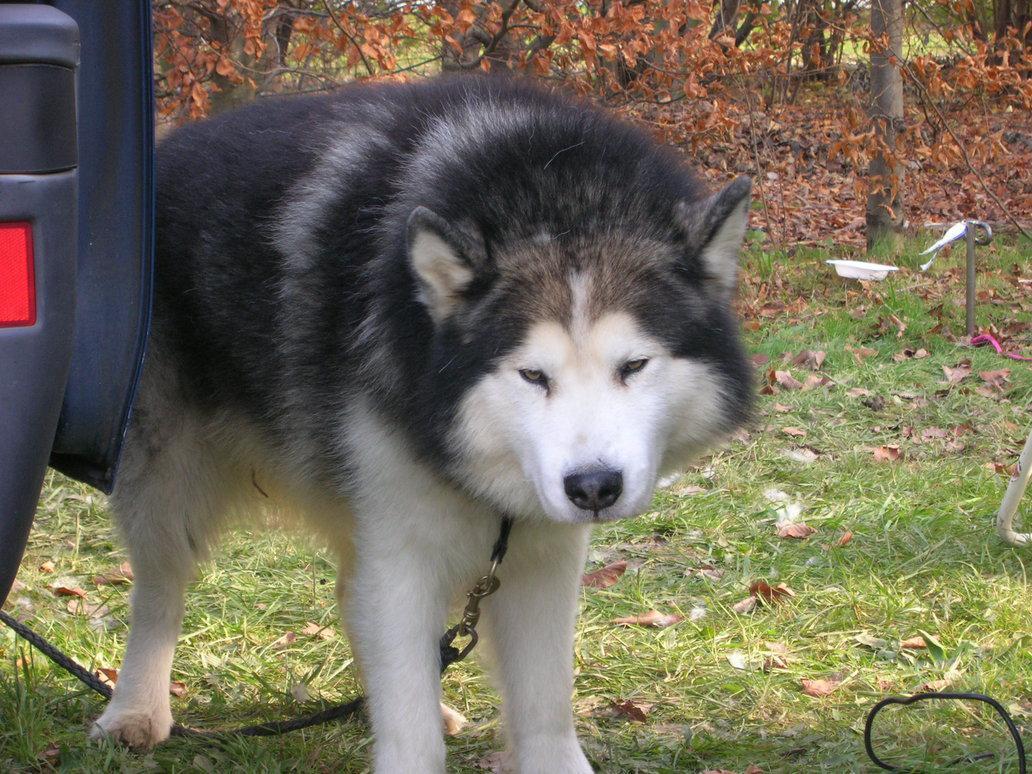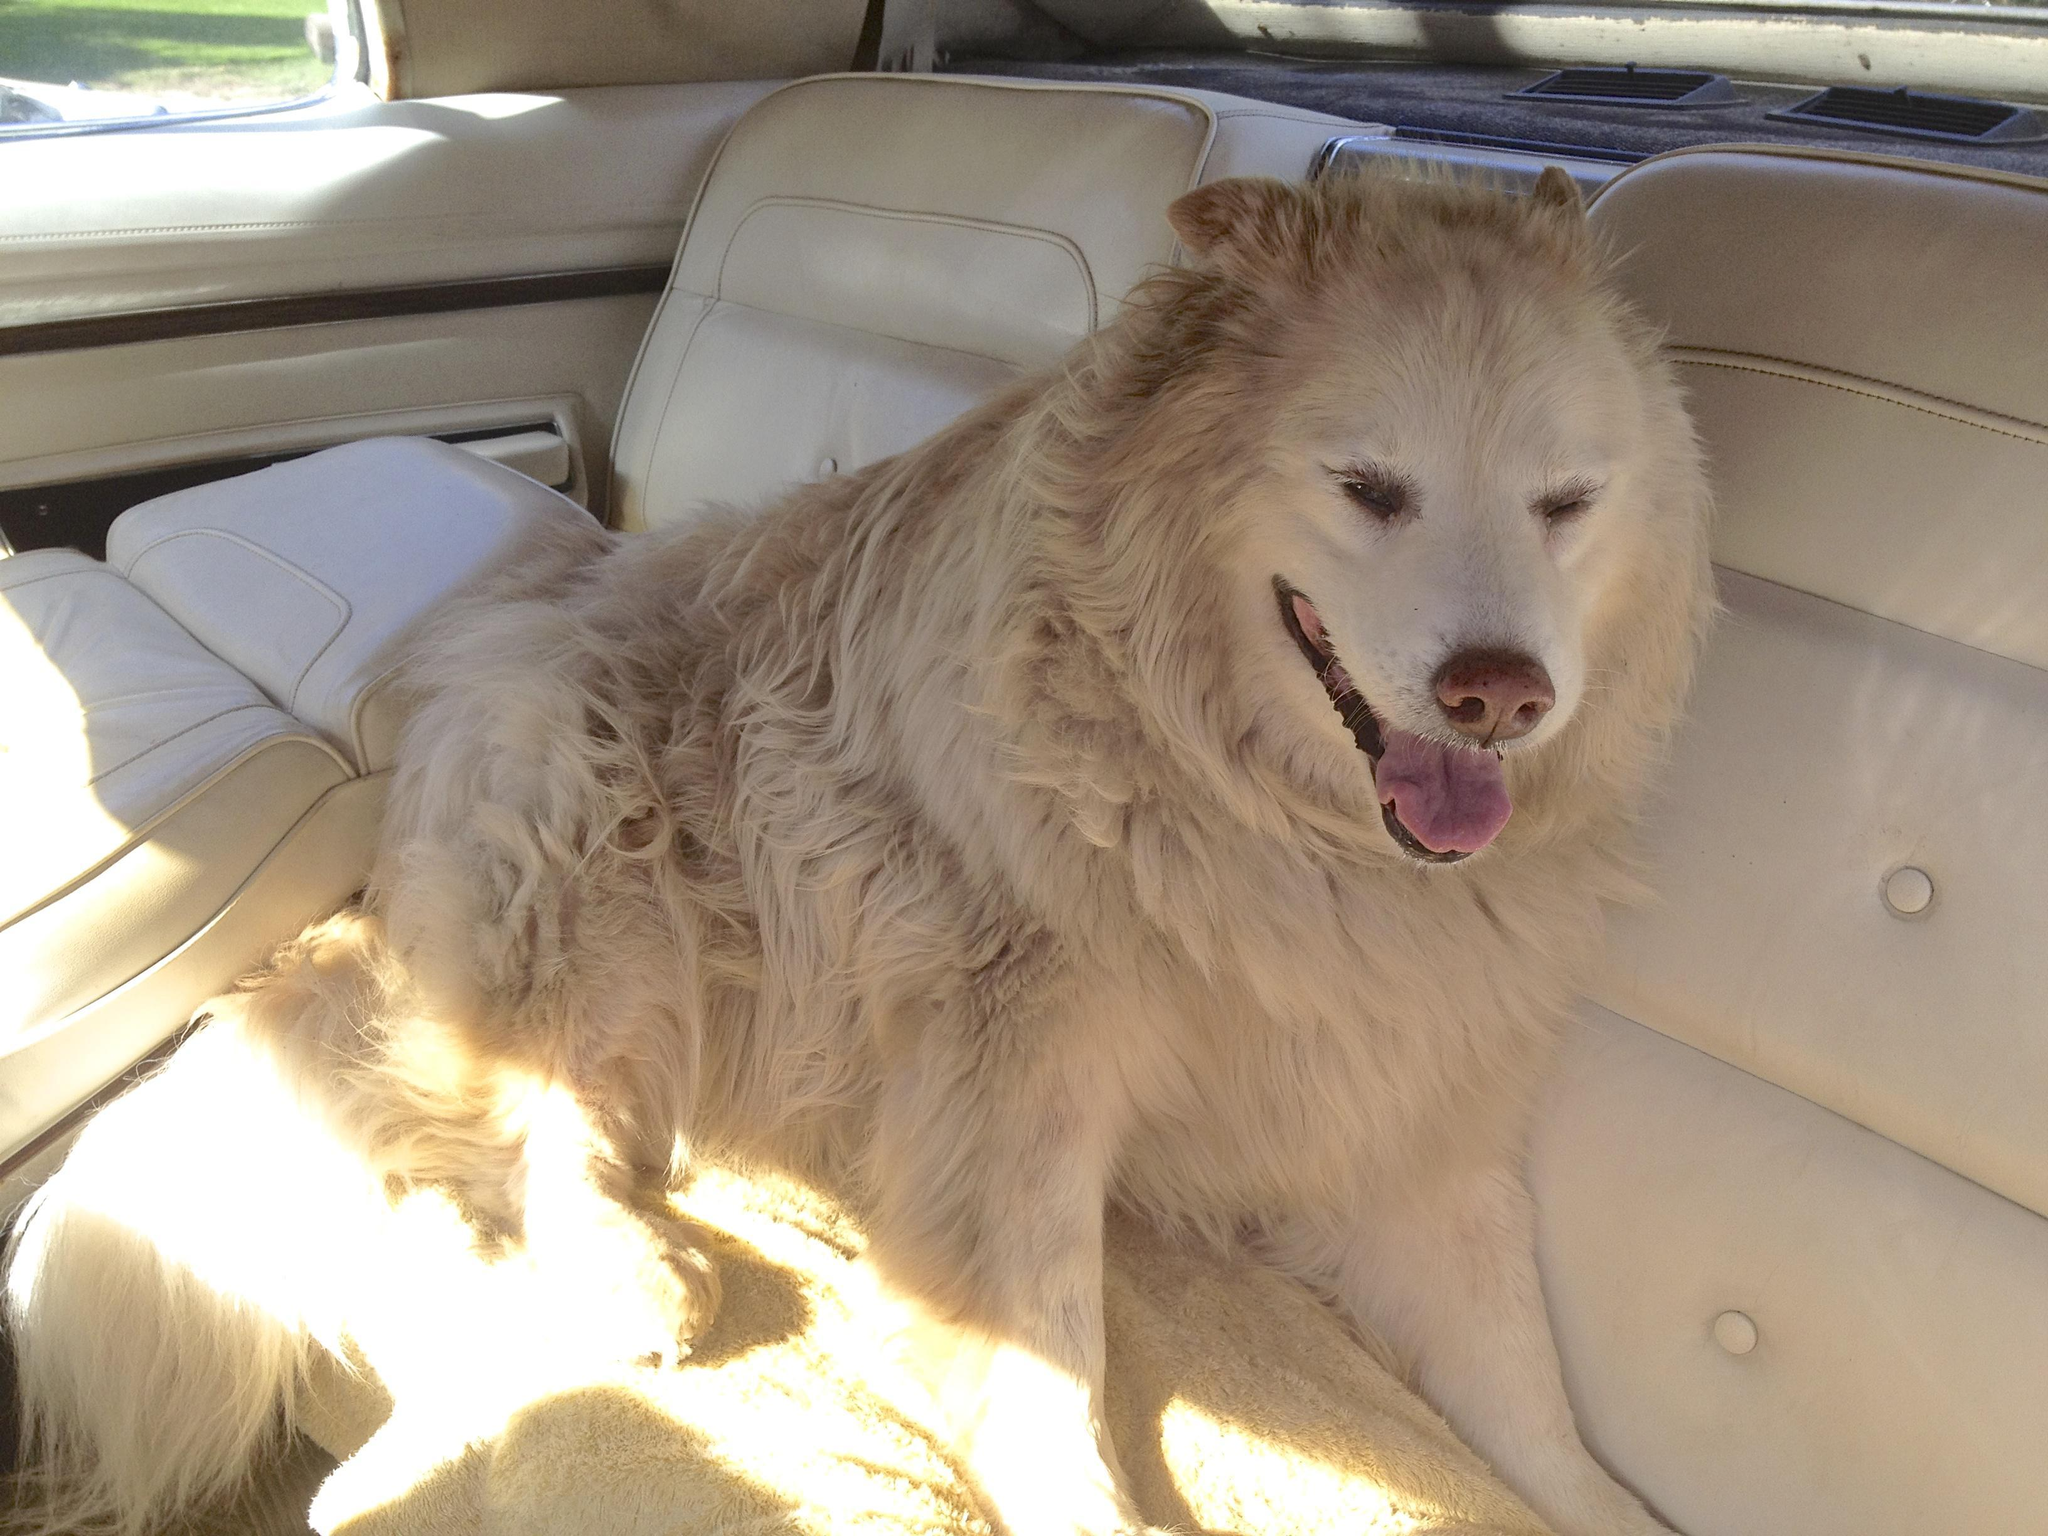The first image is the image on the left, the second image is the image on the right. Analyze the images presented: Is the assertion "The left and right image contains the same number of dogs." valid? Answer yes or no. Yes. The first image is the image on the left, the second image is the image on the right. Examine the images to the left and right. Is the description "A dog is standing in the grass." accurate? Answer yes or no. Yes. 